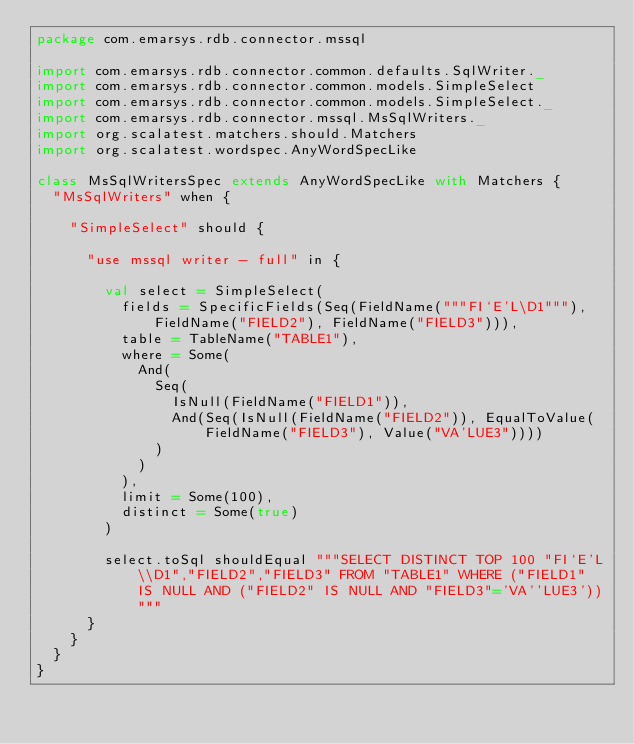<code> <loc_0><loc_0><loc_500><loc_500><_Scala_>package com.emarsys.rdb.connector.mssql

import com.emarsys.rdb.connector.common.defaults.SqlWriter._
import com.emarsys.rdb.connector.common.models.SimpleSelect
import com.emarsys.rdb.connector.common.models.SimpleSelect._
import com.emarsys.rdb.connector.mssql.MsSqlWriters._
import org.scalatest.matchers.should.Matchers
import org.scalatest.wordspec.AnyWordSpecLike

class MsSqlWritersSpec extends AnyWordSpecLike with Matchers {
  "MsSqlWriters" when {

    "SimpleSelect" should {

      "use mssql writer - full" in {

        val select = SimpleSelect(
          fields = SpecificFields(Seq(FieldName("""FI`E'L\D1"""), FieldName("FIELD2"), FieldName("FIELD3"))),
          table = TableName("TABLE1"),
          where = Some(
            And(
              Seq(
                IsNull(FieldName("FIELD1")),
                And(Seq(IsNull(FieldName("FIELD2")), EqualToValue(FieldName("FIELD3"), Value("VA'LUE3"))))
              )
            )
          ),
          limit = Some(100),
          distinct = Some(true)
        )

        select.toSql shouldEqual """SELECT DISTINCT TOP 100 "FI`E'L\\D1","FIELD2","FIELD3" FROM "TABLE1" WHERE ("FIELD1" IS NULL AND ("FIELD2" IS NULL AND "FIELD3"='VA''LUE3'))"""
      }
    }
  }
}
</code> 